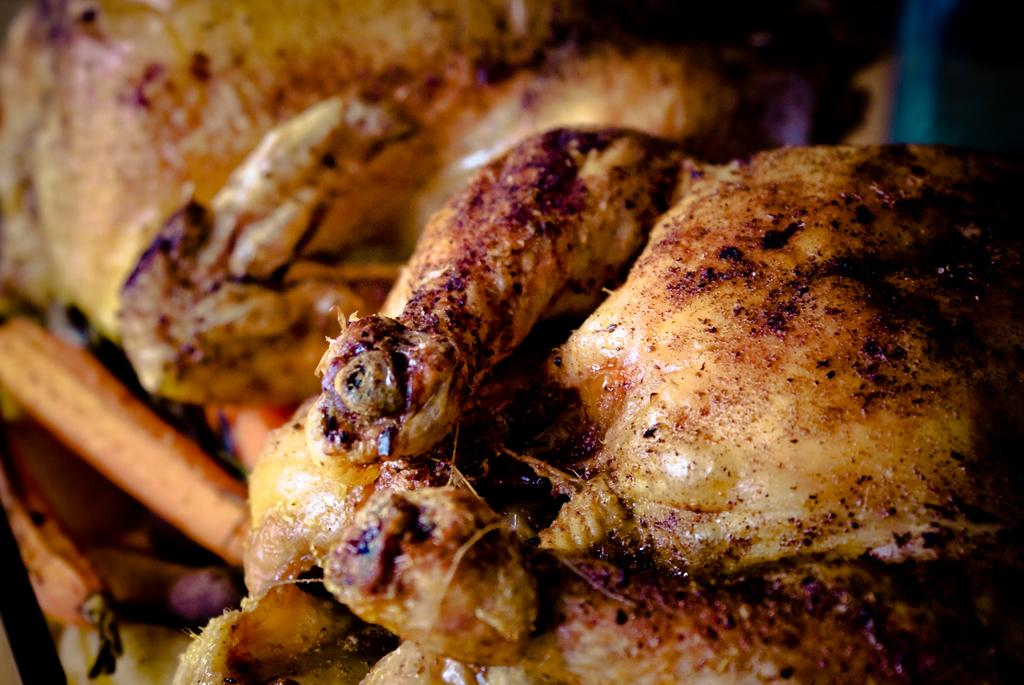What types of items can be seen in the image? There are food items in the image. What type of flower is growing on the food items in the image? There are no flowers present in the image; it only contains food items. 